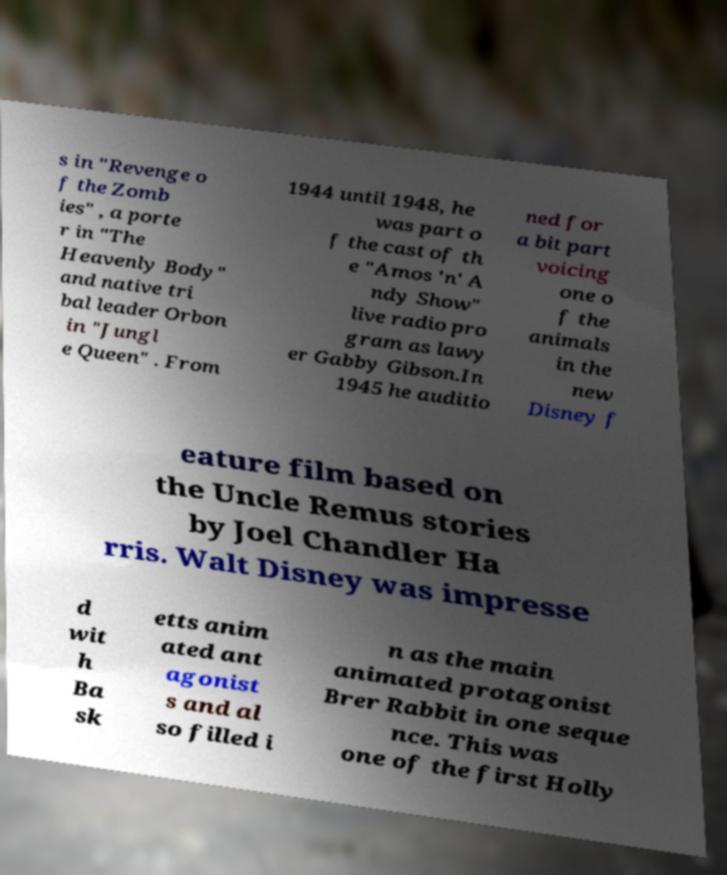Could you assist in decoding the text presented in this image and type it out clearly? s in "Revenge o f the Zomb ies" , a porte r in "The Heavenly Body" and native tri bal leader Orbon in "Jungl e Queen" . From 1944 until 1948, he was part o f the cast of th e "Amos 'n' A ndy Show" live radio pro gram as lawy er Gabby Gibson.In 1945 he auditio ned for a bit part voicing one o f the animals in the new Disney f eature film based on the Uncle Remus stories by Joel Chandler Ha rris. Walt Disney was impresse d wit h Ba sk etts anim ated ant agonist s and al so filled i n as the main animated protagonist Brer Rabbit in one seque nce. This was one of the first Holly 